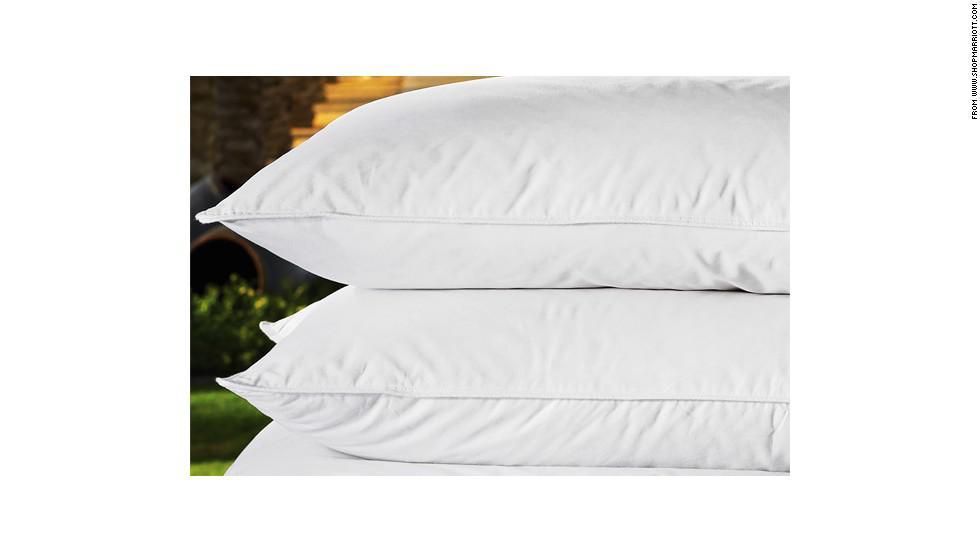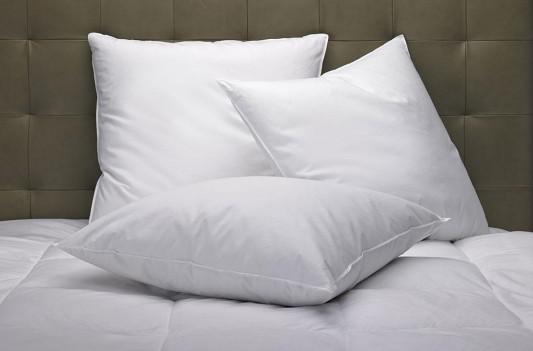The first image is the image on the left, the second image is the image on the right. For the images shown, is this caption "An image includes a cylindrical pillow with beige bands on each end." true? Answer yes or no. No. The first image is the image on the left, the second image is the image on the right. Evaluate the accuracy of this statement regarding the images: "In one image a roll pillow with tan stripes is in front of white rectangular upright bed billows.". Is it true? Answer yes or no. No. 